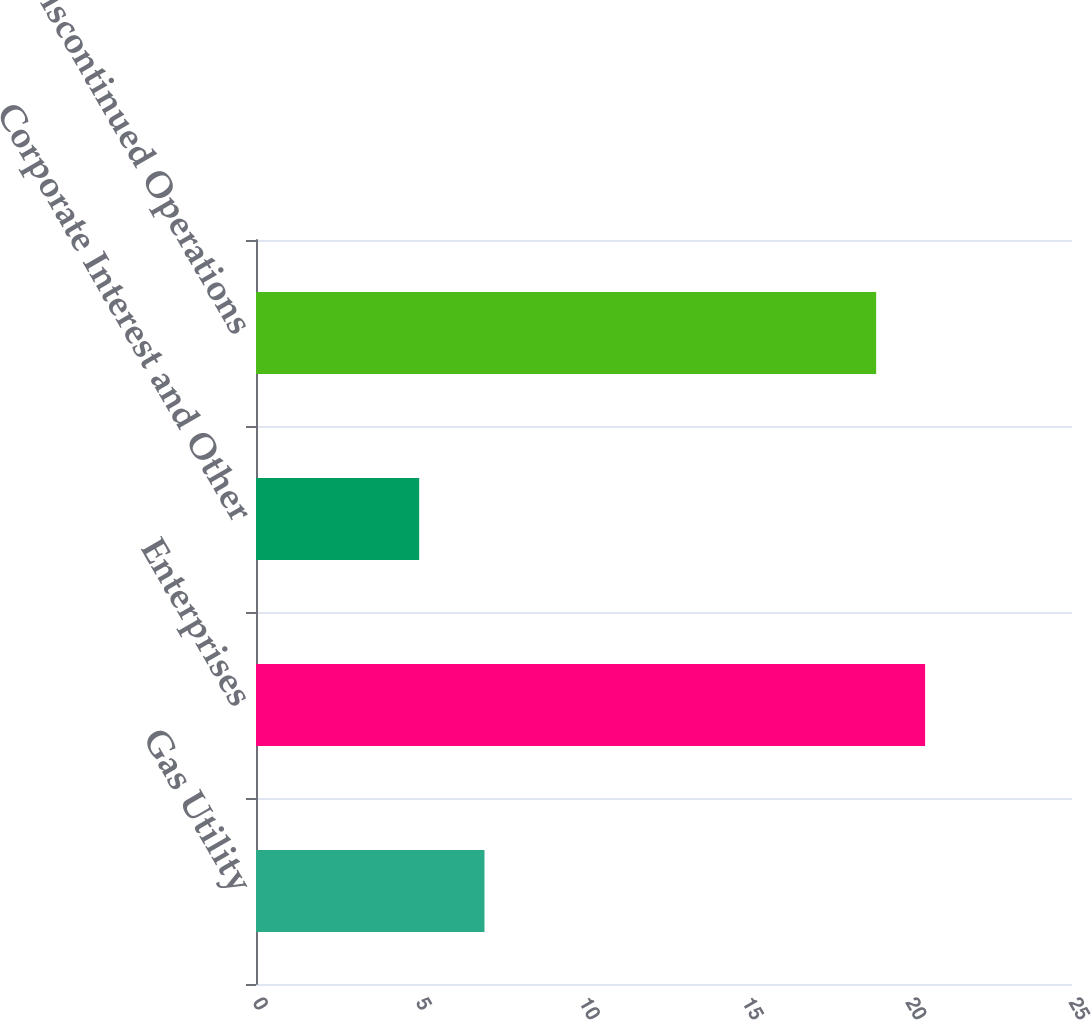Convert chart. <chart><loc_0><loc_0><loc_500><loc_500><bar_chart><fcel>Gas Utility<fcel>Enterprises<fcel>Corporate Interest and Other<fcel>Discontinued Operations<nl><fcel>7<fcel>20.5<fcel>5<fcel>19<nl></chart> 